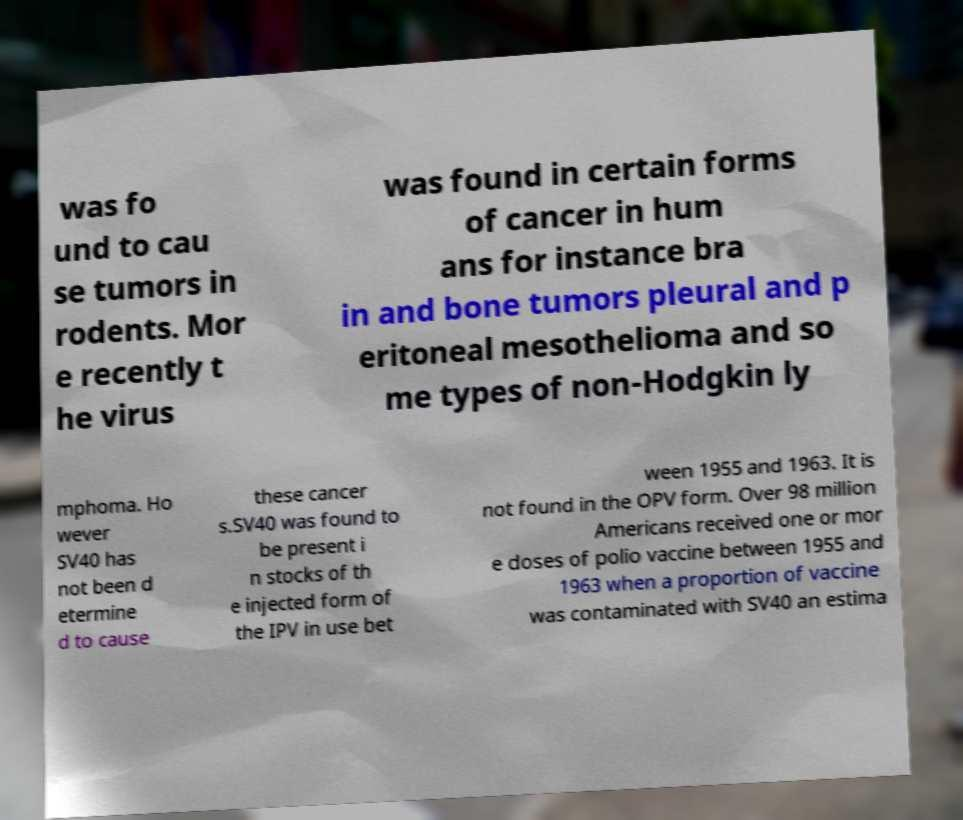Please identify and transcribe the text found in this image. was fo und to cau se tumors in rodents. Mor e recently t he virus was found in certain forms of cancer in hum ans for instance bra in and bone tumors pleural and p eritoneal mesothelioma and so me types of non-Hodgkin ly mphoma. Ho wever SV40 has not been d etermine d to cause these cancer s.SV40 was found to be present i n stocks of th e injected form of the IPV in use bet ween 1955 and 1963. It is not found in the OPV form. Over 98 million Americans received one or mor e doses of polio vaccine between 1955 and 1963 when a proportion of vaccine was contaminated with SV40 an estima 